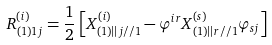Convert formula to latex. <formula><loc_0><loc_0><loc_500><loc_500>R _ { ( 1 ) 1 j } ^ { ( i ) } = \frac { 1 } { 2 } \left [ X _ { ( 1 ) | | j / / 1 } ^ { ( i ) } - \varphi ^ { i r } X _ { ( 1 ) | | r / / 1 } ^ { ( s ) } \varphi _ { s j } \right ]</formula> 